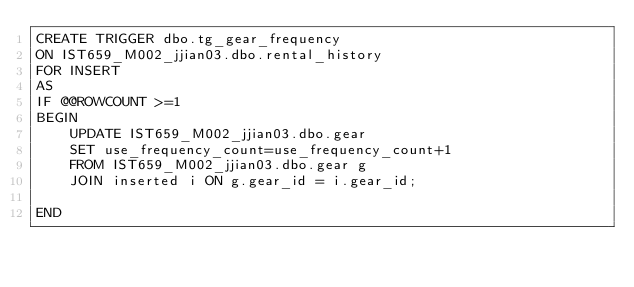<code> <loc_0><loc_0><loc_500><loc_500><_SQL_>CREATE TRIGGER dbo.tg_gear_frequency
ON IST659_M002_jjian03.dbo.rental_history
FOR INSERT
AS
IF @@ROWCOUNT >=1
BEGIN
	UPDATE IST659_M002_jjian03.dbo.gear
	SET use_frequency_count=use_frequency_count+1
	FROM IST659_M002_jjian03.dbo.gear g
	JOIN inserted i ON g.gear_id = i.gear_id;

END </code> 